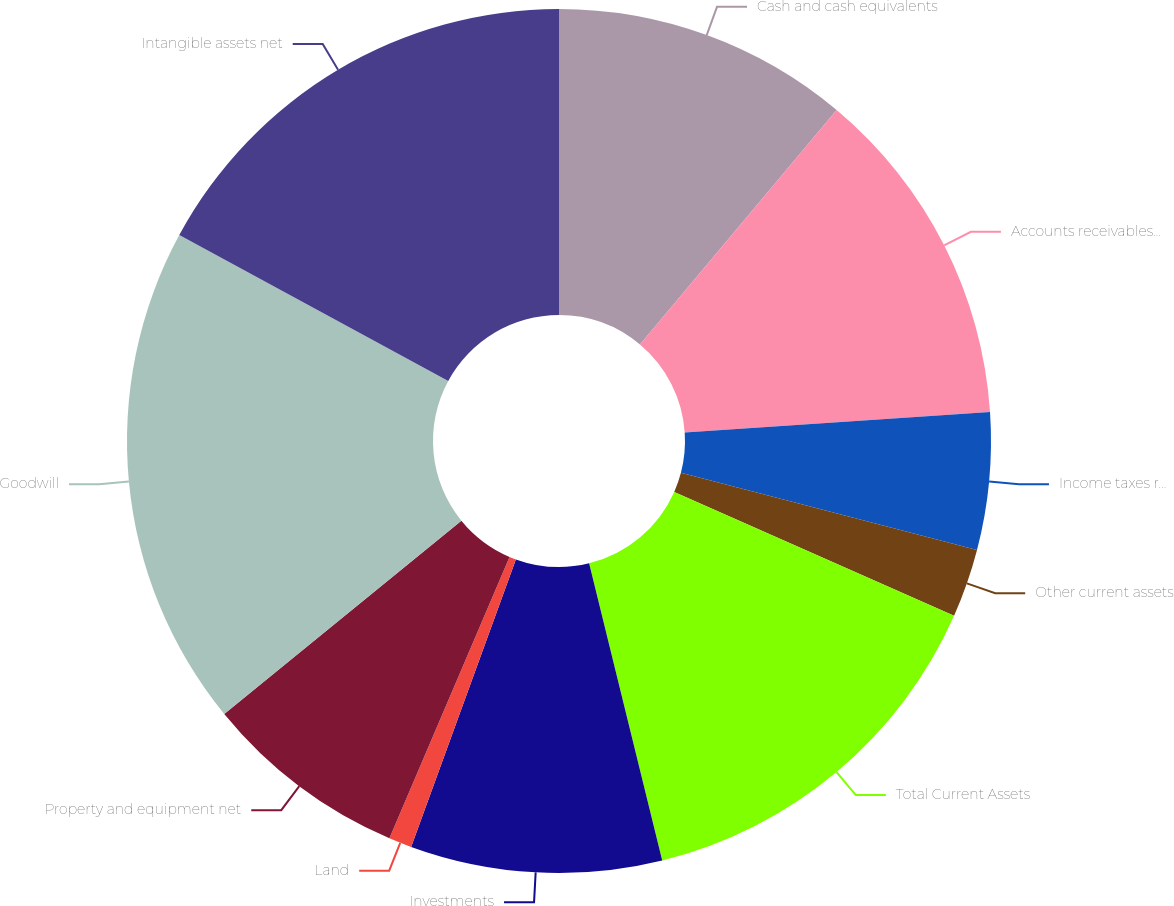Convert chart to OTSL. <chart><loc_0><loc_0><loc_500><loc_500><pie_chart><fcel>Cash and cash equivalents<fcel>Accounts receivables net<fcel>Income taxes receivable<fcel>Other current assets<fcel>Total Current Assets<fcel>Investments<fcel>Land<fcel>Property and equipment net<fcel>Goodwill<fcel>Intangible assets net<nl><fcel>11.11%<fcel>12.82%<fcel>5.13%<fcel>2.57%<fcel>14.53%<fcel>9.4%<fcel>0.86%<fcel>7.69%<fcel>18.8%<fcel>17.09%<nl></chart> 